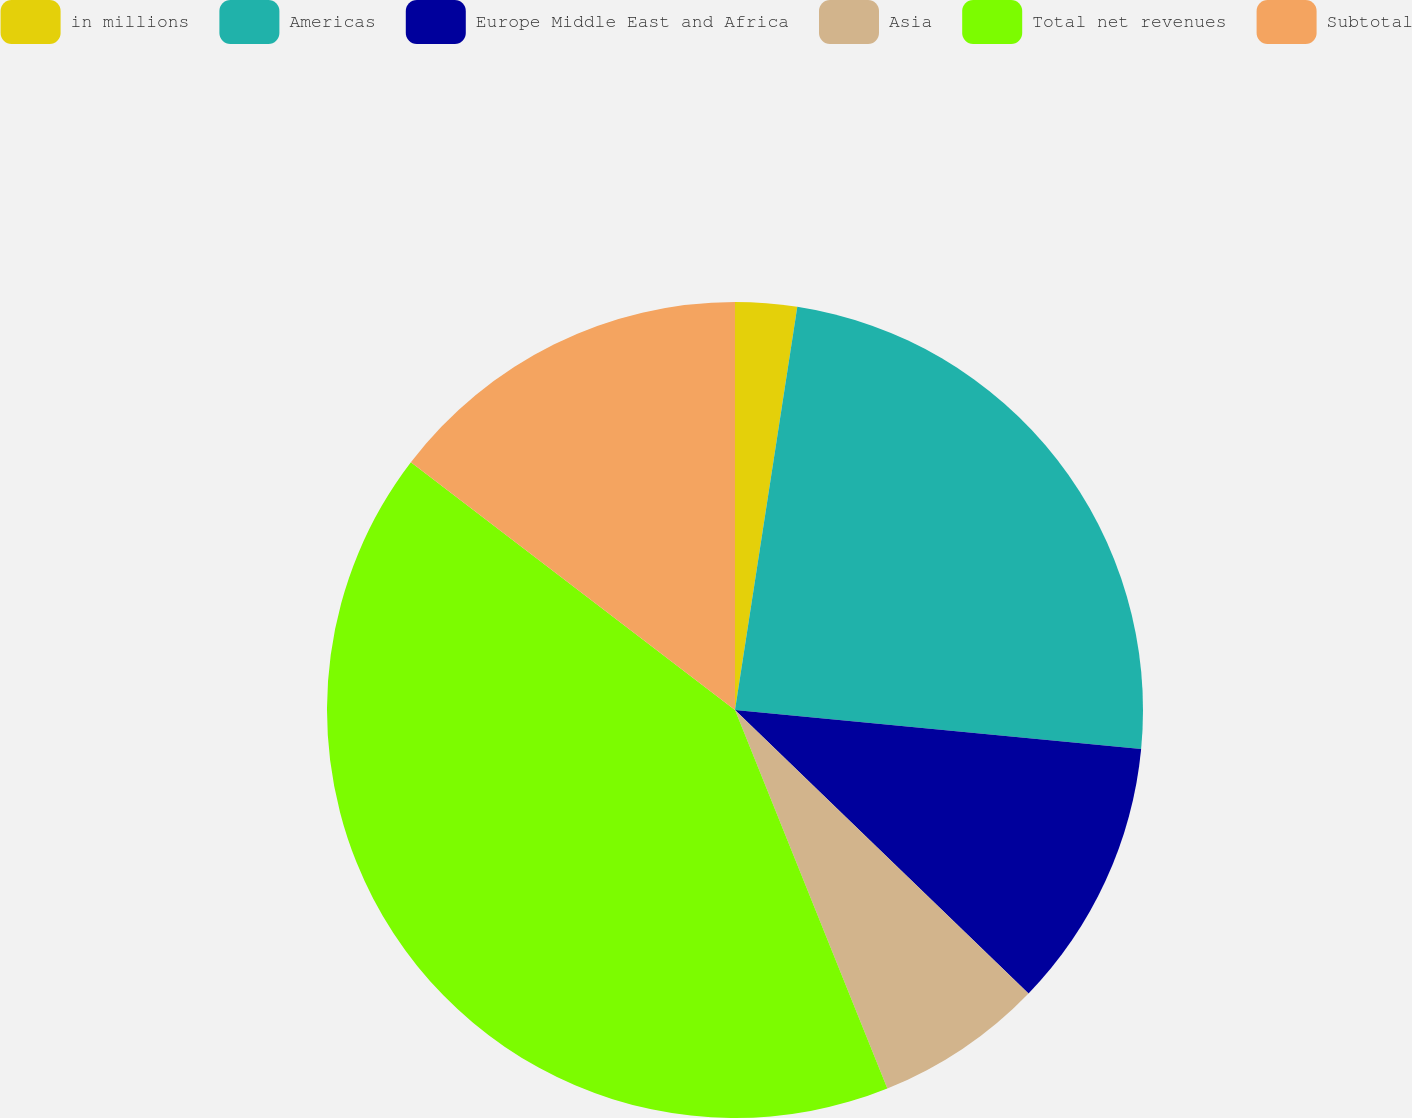Convert chart. <chart><loc_0><loc_0><loc_500><loc_500><pie_chart><fcel>in millions<fcel>Americas<fcel>Europe Middle East and Africa<fcel>Asia<fcel>Total net revenues<fcel>Subtotal<nl><fcel>2.44%<fcel>24.08%<fcel>10.7%<fcel>6.69%<fcel>41.48%<fcel>14.61%<nl></chart> 